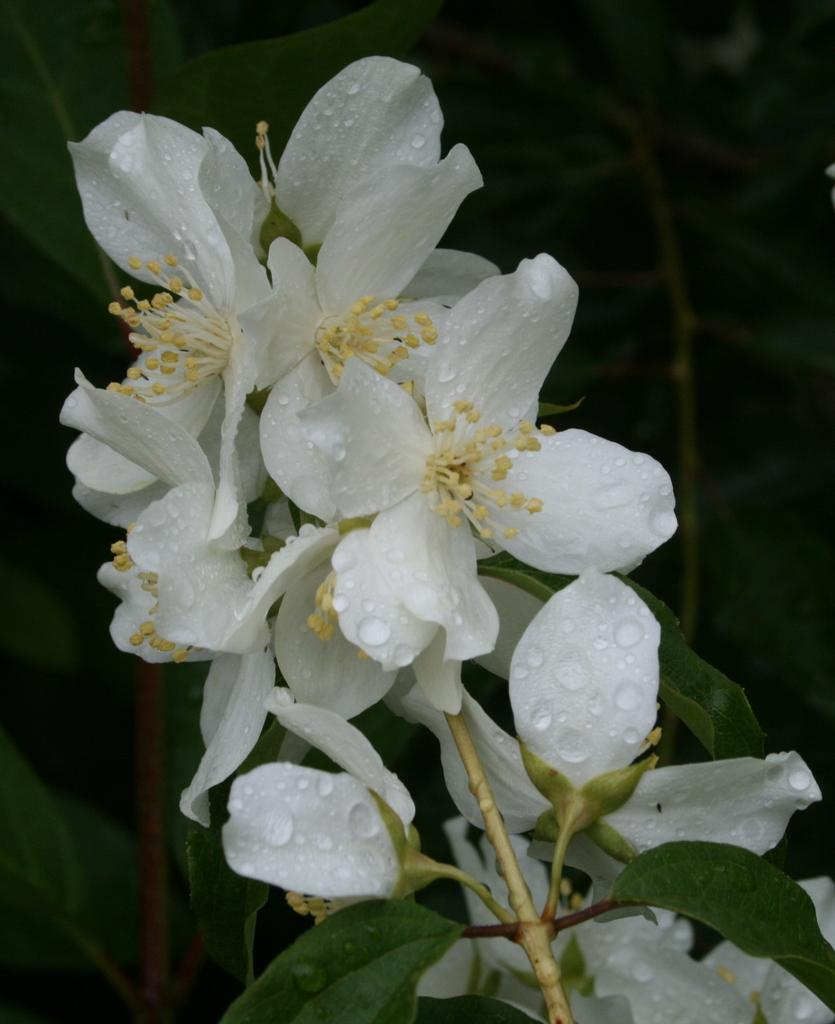What is the main subject of the image? The main subject of the image is a stem with white flowers. Can you describe the flowers in more detail? The flowers have white petals, and there are water droplets on the petals. What can be seen in the background of the image? The backdrop of the image includes plants. How would you describe the lighting in the image? The image appears to be a bit dark. How many beggars are visible in the image? There are no beggars present in the image; it features a stem with white flowers. What type of behavior can be observed in the spiders in the image? There are no spiders present in the image, so their behavior cannot be observed. 